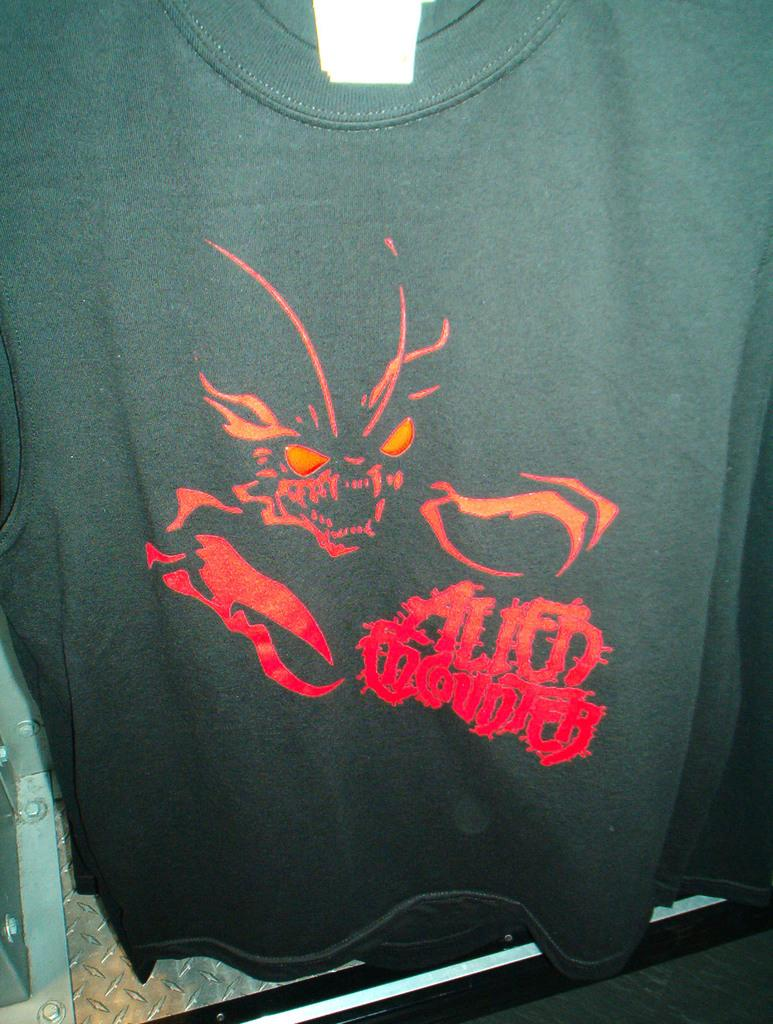What type of clothing is visible in the image? There is a black t-shirt in the image. What is depicted on the t-shirt? The t-shirt has a ghost picture on it. Are there any words or letters on the t-shirt? Yes, there is text written on the t-shirt. What can be seen on the left side at the bottom of the image? There is a metal object on the left side at the bottom of the image. What color is the knee of the person wearing the t-shirt in the image? There is no person wearing the t-shirt in the image, so it is not possible to determine the color of their knee. 